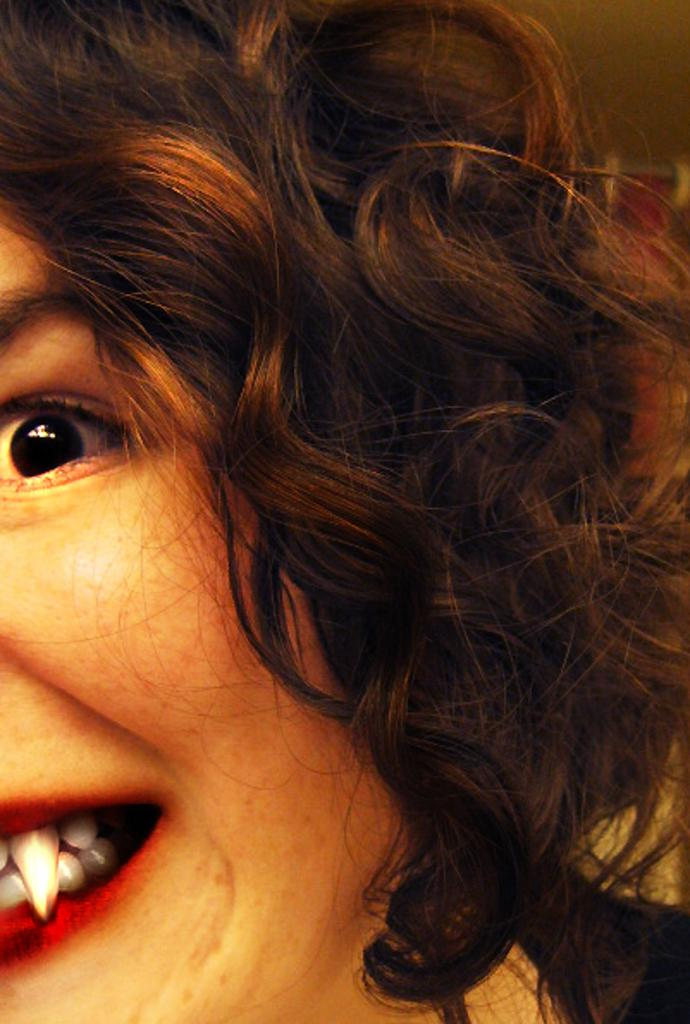Who is present in the image? There is a woman in the image. What type of trees can be seen in the background of the image? There is no background or trees visible in the image; it only features a woman. 